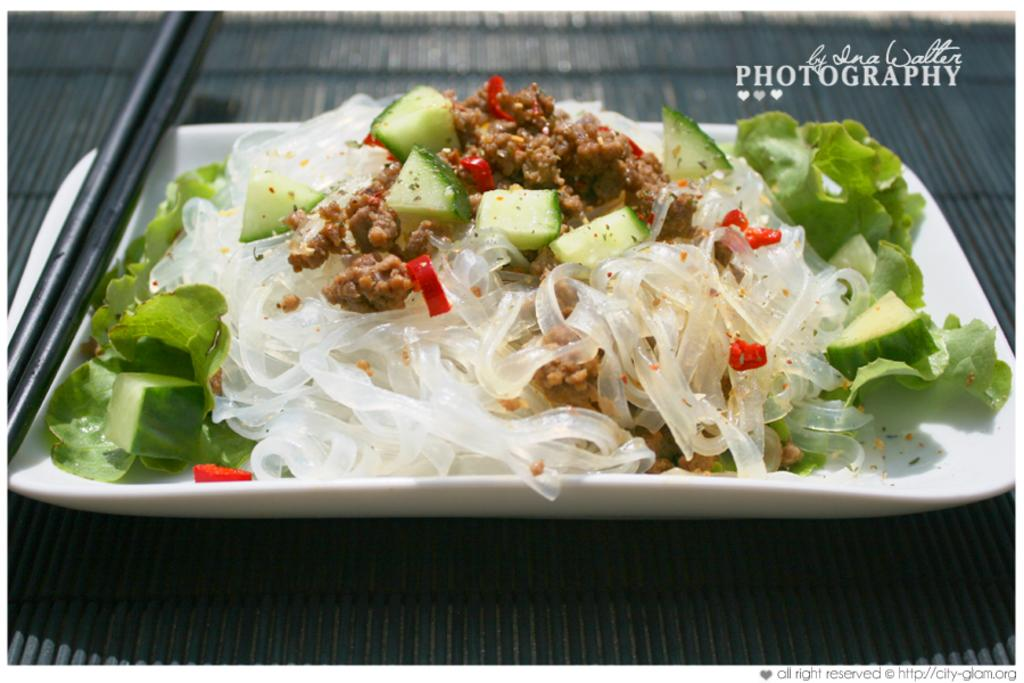What is on the tray in the image? There are vegetable pieces, leaves, and other food items on the tray. What color is the tray? The tray is white in color. Where is the tray located in the image? The tray is on a surface. What can be seen in the background of the image? The background is gray in color. How many sisters are present in the image? There are no sisters present in the image; it features a tray with food items. What type of ear is visible in the image? There is no ear visible in the image; it only shows a tray with food items and a gray background. 